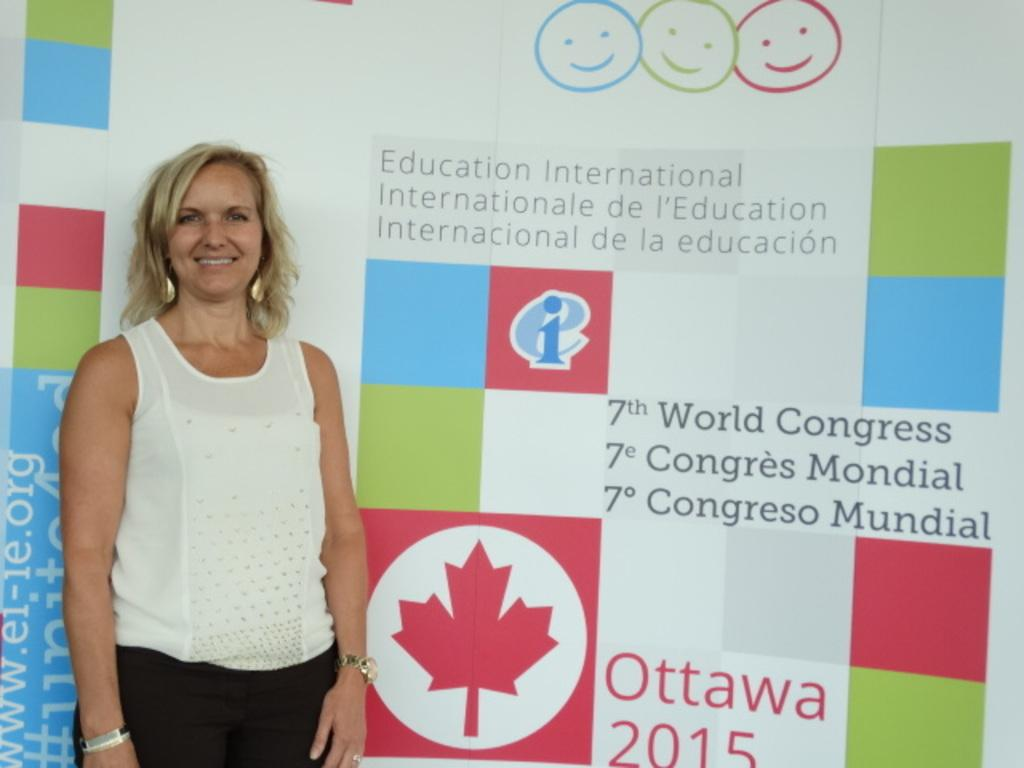Who is present in the image? There is a woman in the image. Where is the woman located in the image? The woman is standing on the left side. What can be seen in the background of the image? There is a hoarding in the background of the image. What type of cap is the woman wearing in the image? There is no cap visible in the image; the woman is not wearing any headgear. 